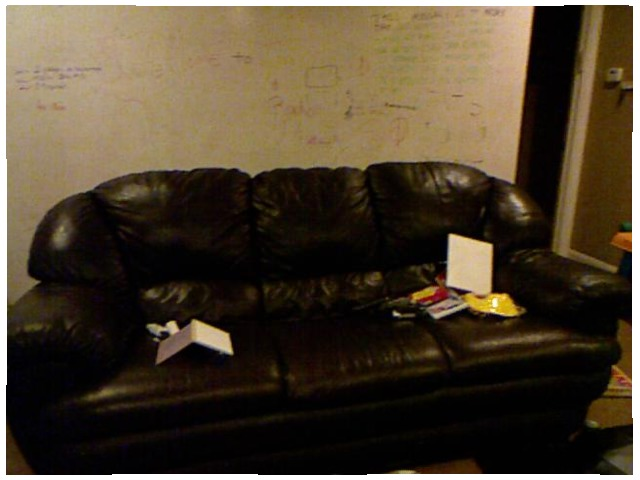<image>
Can you confirm if the wall is above the paper? No. The wall is not positioned above the paper. The vertical arrangement shows a different relationship. Is the couch to the right of the wall? No. The couch is not to the right of the wall. The horizontal positioning shows a different relationship. Where is the sofa in relation to the wall? Is it next to the wall? Yes. The sofa is positioned adjacent to the wall, located nearby in the same general area. Where is the sofa in relation to the remote control? Is it next to the remote control? No. The sofa is not positioned next to the remote control. They are located in different areas of the scene. 